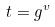<formula> <loc_0><loc_0><loc_500><loc_500>t = g ^ { v }</formula> 